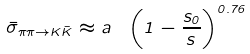Convert formula to latex. <formula><loc_0><loc_0><loc_500><loc_500>\bar { \sigma } _ { \pi \pi \to K \bar { K } } \approx a \ \left ( 1 - \frac { s _ { 0 } } { s } \right ) ^ { 0 . 7 6 }</formula> 